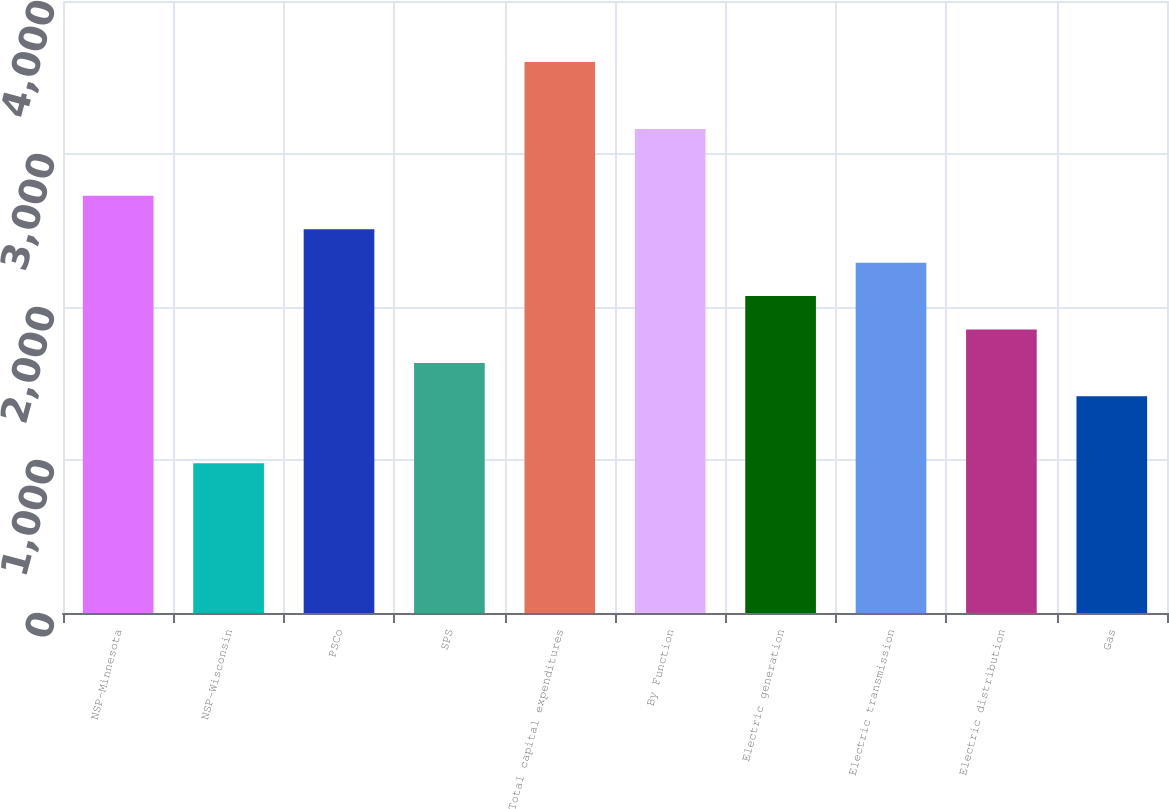<chart> <loc_0><loc_0><loc_500><loc_500><bar_chart><fcel>NSP-Minnesota<fcel>NSP-Wisconsin<fcel>PSCo<fcel>SPS<fcel>Total capital expenditures<fcel>By Function<fcel>Electric generation<fcel>Electric transmission<fcel>Electric distribution<fcel>Gas<nl><fcel>2727<fcel>979<fcel>2508.5<fcel>1634.5<fcel>3601<fcel>3164<fcel>2071.5<fcel>2290<fcel>1853<fcel>1416<nl></chart> 